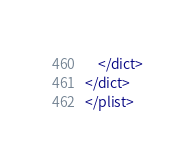<code> <loc_0><loc_0><loc_500><loc_500><_XML_>	</dict>
</dict>
</plist>
</code> 